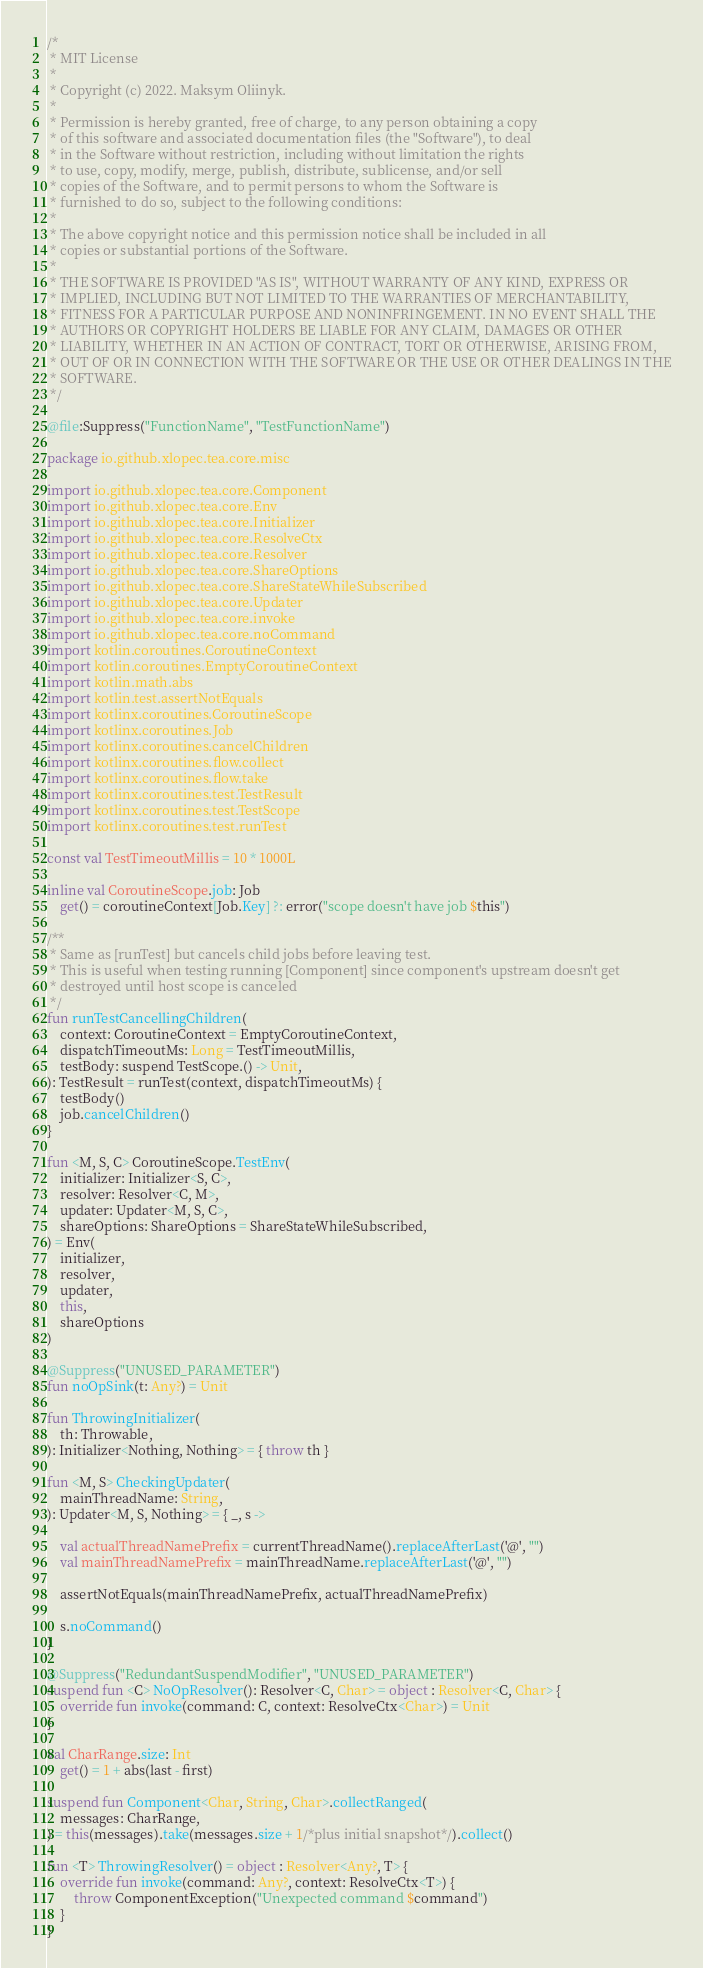Convert code to text. <code><loc_0><loc_0><loc_500><loc_500><_Kotlin_>/*
 * MIT License
 *
 * Copyright (c) 2022. Maksym Oliinyk.
 *
 * Permission is hereby granted, free of charge, to any person obtaining a copy
 * of this software and associated documentation files (the "Software"), to deal
 * in the Software without restriction, including without limitation the rights
 * to use, copy, modify, merge, publish, distribute, sublicense, and/or sell
 * copies of the Software, and to permit persons to whom the Software is
 * furnished to do so, subject to the following conditions:
 *
 * The above copyright notice and this permission notice shall be included in all
 * copies or substantial portions of the Software.
 *
 * THE SOFTWARE IS PROVIDED "AS IS", WITHOUT WARRANTY OF ANY KIND, EXPRESS OR
 * IMPLIED, INCLUDING BUT NOT LIMITED TO THE WARRANTIES OF MERCHANTABILITY,
 * FITNESS FOR A PARTICULAR PURPOSE AND NONINFRINGEMENT. IN NO EVENT SHALL THE
 * AUTHORS OR COPYRIGHT HOLDERS BE LIABLE FOR ANY CLAIM, DAMAGES OR OTHER
 * LIABILITY, WHETHER IN AN ACTION OF CONTRACT, TORT OR OTHERWISE, ARISING FROM,
 * OUT OF OR IN CONNECTION WITH THE SOFTWARE OR THE USE OR OTHER DEALINGS IN THE
 * SOFTWARE.
 */

@file:Suppress("FunctionName", "TestFunctionName")

package io.github.xlopec.tea.core.misc

import io.github.xlopec.tea.core.Component
import io.github.xlopec.tea.core.Env
import io.github.xlopec.tea.core.Initializer
import io.github.xlopec.tea.core.ResolveCtx
import io.github.xlopec.tea.core.Resolver
import io.github.xlopec.tea.core.ShareOptions
import io.github.xlopec.tea.core.ShareStateWhileSubscribed
import io.github.xlopec.tea.core.Updater
import io.github.xlopec.tea.core.invoke
import io.github.xlopec.tea.core.noCommand
import kotlin.coroutines.CoroutineContext
import kotlin.coroutines.EmptyCoroutineContext
import kotlin.math.abs
import kotlin.test.assertNotEquals
import kotlinx.coroutines.CoroutineScope
import kotlinx.coroutines.Job
import kotlinx.coroutines.cancelChildren
import kotlinx.coroutines.flow.collect
import kotlinx.coroutines.flow.take
import kotlinx.coroutines.test.TestResult
import kotlinx.coroutines.test.TestScope
import kotlinx.coroutines.test.runTest

const val TestTimeoutMillis = 10 * 1000L

inline val CoroutineScope.job: Job
    get() = coroutineContext[Job.Key] ?: error("scope doesn't have job $this")

/**
 * Same as [runTest] but cancels child jobs before leaving test.
 * This is useful when testing running [Component] since component's upstream doesn't get
 * destroyed until host scope is canceled
 */
fun runTestCancellingChildren(
    context: CoroutineContext = EmptyCoroutineContext,
    dispatchTimeoutMs: Long = TestTimeoutMillis,
    testBody: suspend TestScope.() -> Unit,
): TestResult = runTest(context, dispatchTimeoutMs) {
    testBody()
    job.cancelChildren()
}

fun <M, S, C> CoroutineScope.TestEnv(
    initializer: Initializer<S, C>,
    resolver: Resolver<C, M>,
    updater: Updater<M, S, C>,
    shareOptions: ShareOptions = ShareStateWhileSubscribed,
) = Env(
    initializer,
    resolver,
    updater,
    this,
    shareOptions
)

@Suppress("UNUSED_PARAMETER")
fun noOpSink(t: Any?) = Unit

fun ThrowingInitializer(
    th: Throwable,
): Initializer<Nothing, Nothing> = { throw th }

fun <M, S> CheckingUpdater(
    mainThreadName: String,
): Updater<M, S, Nothing> = { _, s ->

    val actualThreadNamePrefix = currentThreadName().replaceAfterLast('@', "")
    val mainThreadNamePrefix = mainThreadName.replaceAfterLast('@', "")

    assertNotEquals(mainThreadNamePrefix, actualThreadNamePrefix)

    s.noCommand()
}

@Suppress("RedundantSuspendModifier", "UNUSED_PARAMETER")
suspend fun <C> NoOpResolver(): Resolver<C, Char> = object : Resolver<C, Char> {
    override fun invoke(command: C, context: ResolveCtx<Char>) = Unit
}

val CharRange.size: Int
    get() = 1 + abs(last - first)

suspend fun Component<Char, String, Char>.collectRanged(
    messages: CharRange,
) = this(messages).take(messages.size + 1/*plus initial snapshot*/).collect()

fun <T> ThrowingResolver() = object : Resolver<Any?, T> {
    override fun invoke(command: Any?, context: ResolveCtx<T>) {
        throw ComponentException("Unexpected command $command")
    }
}
</code> 